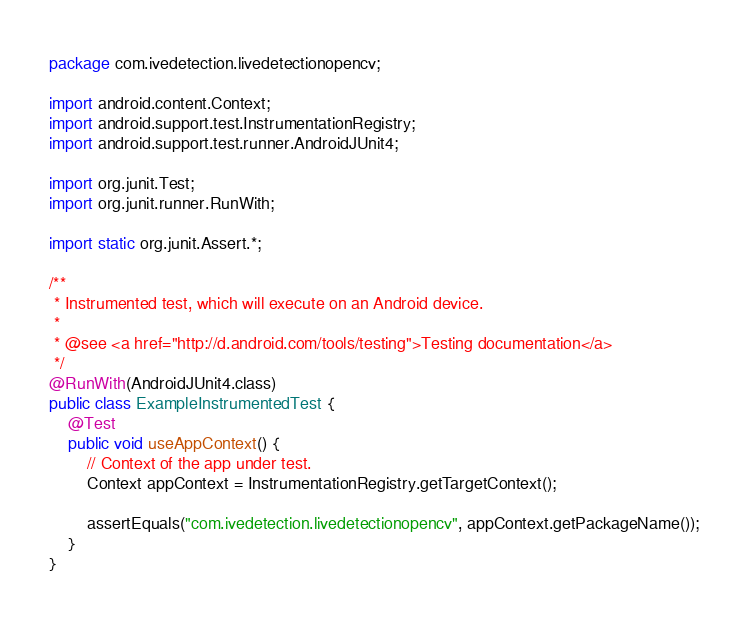Convert code to text. <code><loc_0><loc_0><loc_500><loc_500><_Java_>package com.ivedetection.livedetectionopencv;

import android.content.Context;
import android.support.test.InstrumentationRegistry;
import android.support.test.runner.AndroidJUnit4;

import org.junit.Test;
import org.junit.runner.RunWith;

import static org.junit.Assert.*;

/**
 * Instrumented test, which will execute on an Android device.
 *
 * @see <a href="http://d.android.com/tools/testing">Testing documentation</a>
 */
@RunWith(AndroidJUnit4.class)
public class ExampleInstrumentedTest {
    @Test
    public void useAppContext() {
        // Context of the app under test.
        Context appContext = InstrumentationRegistry.getTargetContext();

        assertEquals("com.ivedetection.livedetectionopencv", appContext.getPackageName());
    }
}
</code> 